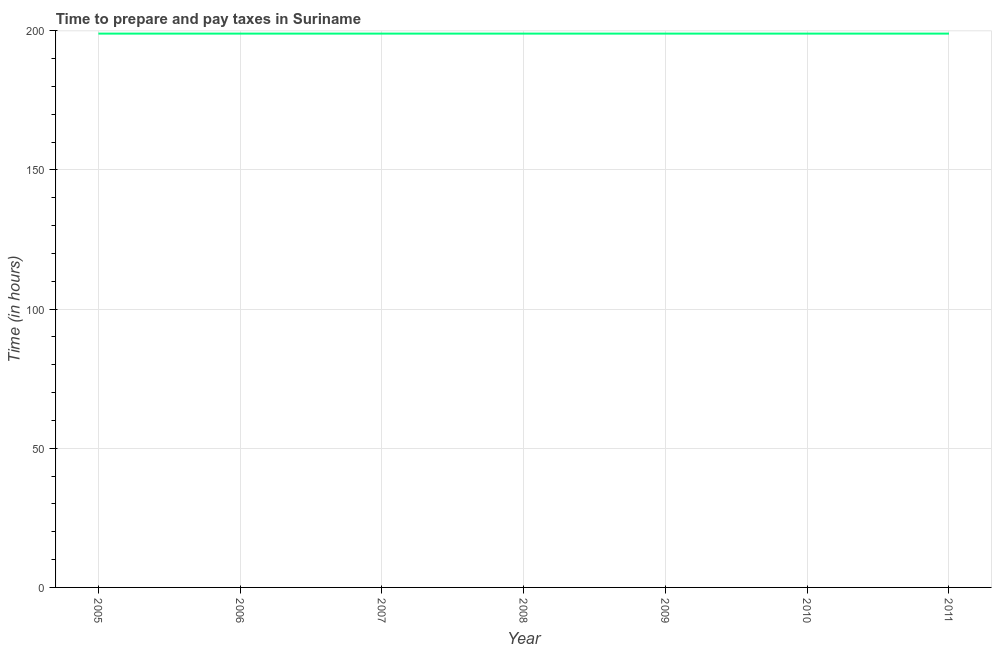What is the time to prepare and pay taxes in 2009?
Offer a terse response. 199. Across all years, what is the maximum time to prepare and pay taxes?
Ensure brevity in your answer.  199. Across all years, what is the minimum time to prepare and pay taxes?
Your answer should be very brief. 199. In which year was the time to prepare and pay taxes minimum?
Make the answer very short. 2005. What is the sum of the time to prepare and pay taxes?
Provide a succinct answer. 1393. What is the average time to prepare and pay taxes per year?
Your response must be concise. 199. What is the median time to prepare and pay taxes?
Offer a terse response. 199. In how many years, is the time to prepare and pay taxes greater than 40 hours?
Offer a very short reply. 7. Do a majority of the years between 2010 and 2005 (inclusive) have time to prepare and pay taxes greater than 80 hours?
Keep it short and to the point. Yes. What is the difference between the highest and the lowest time to prepare and pay taxes?
Make the answer very short. 0. Does the time to prepare and pay taxes monotonically increase over the years?
Keep it short and to the point. No. How many lines are there?
Give a very brief answer. 1. What is the difference between two consecutive major ticks on the Y-axis?
Keep it short and to the point. 50. Are the values on the major ticks of Y-axis written in scientific E-notation?
Give a very brief answer. No. Does the graph contain any zero values?
Provide a short and direct response. No. What is the title of the graph?
Your answer should be compact. Time to prepare and pay taxes in Suriname. What is the label or title of the Y-axis?
Give a very brief answer. Time (in hours). What is the Time (in hours) in 2005?
Keep it short and to the point. 199. What is the Time (in hours) of 2006?
Make the answer very short. 199. What is the Time (in hours) in 2007?
Make the answer very short. 199. What is the Time (in hours) of 2008?
Offer a terse response. 199. What is the Time (in hours) in 2009?
Your answer should be compact. 199. What is the Time (in hours) in 2010?
Keep it short and to the point. 199. What is the Time (in hours) of 2011?
Keep it short and to the point. 199. What is the difference between the Time (in hours) in 2005 and 2007?
Provide a succinct answer. 0. What is the difference between the Time (in hours) in 2005 and 2009?
Ensure brevity in your answer.  0. What is the difference between the Time (in hours) in 2005 and 2011?
Ensure brevity in your answer.  0. What is the difference between the Time (in hours) in 2006 and 2007?
Ensure brevity in your answer.  0. What is the difference between the Time (in hours) in 2006 and 2008?
Your answer should be compact. 0. What is the difference between the Time (in hours) in 2006 and 2011?
Ensure brevity in your answer.  0. What is the difference between the Time (in hours) in 2007 and 2008?
Your answer should be very brief. 0. What is the difference between the Time (in hours) in 2007 and 2011?
Your answer should be very brief. 0. What is the difference between the Time (in hours) in 2008 and 2009?
Keep it short and to the point. 0. What is the difference between the Time (in hours) in 2009 and 2010?
Provide a short and direct response. 0. What is the ratio of the Time (in hours) in 2005 to that in 2006?
Make the answer very short. 1. What is the ratio of the Time (in hours) in 2005 to that in 2007?
Your answer should be compact. 1. What is the ratio of the Time (in hours) in 2006 to that in 2007?
Make the answer very short. 1. What is the ratio of the Time (in hours) in 2006 to that in 2009?
Your answer should be very brief. 1. What is the ratio of the Time (in hours) in 2006 to that in 2010?
Offer a terse response. 1. What is the ratio of the Time (in hours) in 2006 to that in 2011?
Ensure brevity in your answer.  1. What is the ratio of the Time (in hours) in 2007 to that in 2008?
Your response must be concise. 1. What is the ratio of the Time (in hours) in 2007 to that in 2011?
Provide a succinct answer. 1. What is the ratio of the Time (in hours) in 2008 to that in 2009?
Offer a terse response. 1. What is the ratio of the Time (in hours) in 2008 to that in 2011?
Make the answer very short. 1. What is the ratio of the Time (in hours) in 2009 to that in 2010?
Your answer should be very brief. 1. 